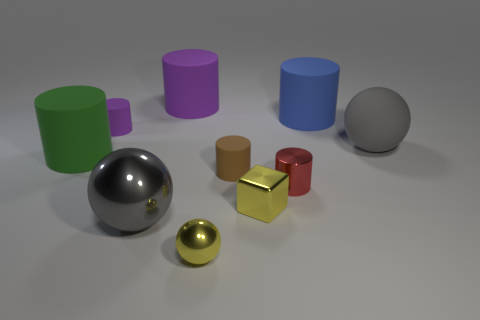What number of things are either small rubber cylinders that are behind the tiny brown rubber cylinder or big cyan metal cylinders?
Make the answer very short. 1. What is the shape of the blue object that is the same size as the green thing?
Keep it short and to the point. Cylinder. Do the yellow thing that is on the right side of the brown cylinder and the sphere that is to the left of the big purple matte cylinder have the same size?
Make the answer very short. No. What is the color of the sphere that is the same material as the large blue object?
Your answer should be compact. Gray. Do the gray sphere that is left of the gray matte ball and the tiny ball that is on the right side of the large purple rubber cylinder have the same material?
Provide a succinct answer. Yes. Is there a blue cylinder that has the same size as the matte ball?
Offer a terse response. Yes. There is a shiny ball behind the metallic ball that is to the right of the large gray metal thing; what size is it?
Provide a short and direct response. Large. What number of small things are the same color as the metallic block?
Offer a very short reply. 1. What is the shape of the small rubber object behind the gray ball that is to the right of the large metal thing?
Give a very brief answer. Cylinder. How many small blocks have the same material as the tiny purple thing?
Ensure brevity in your answer.  0. 